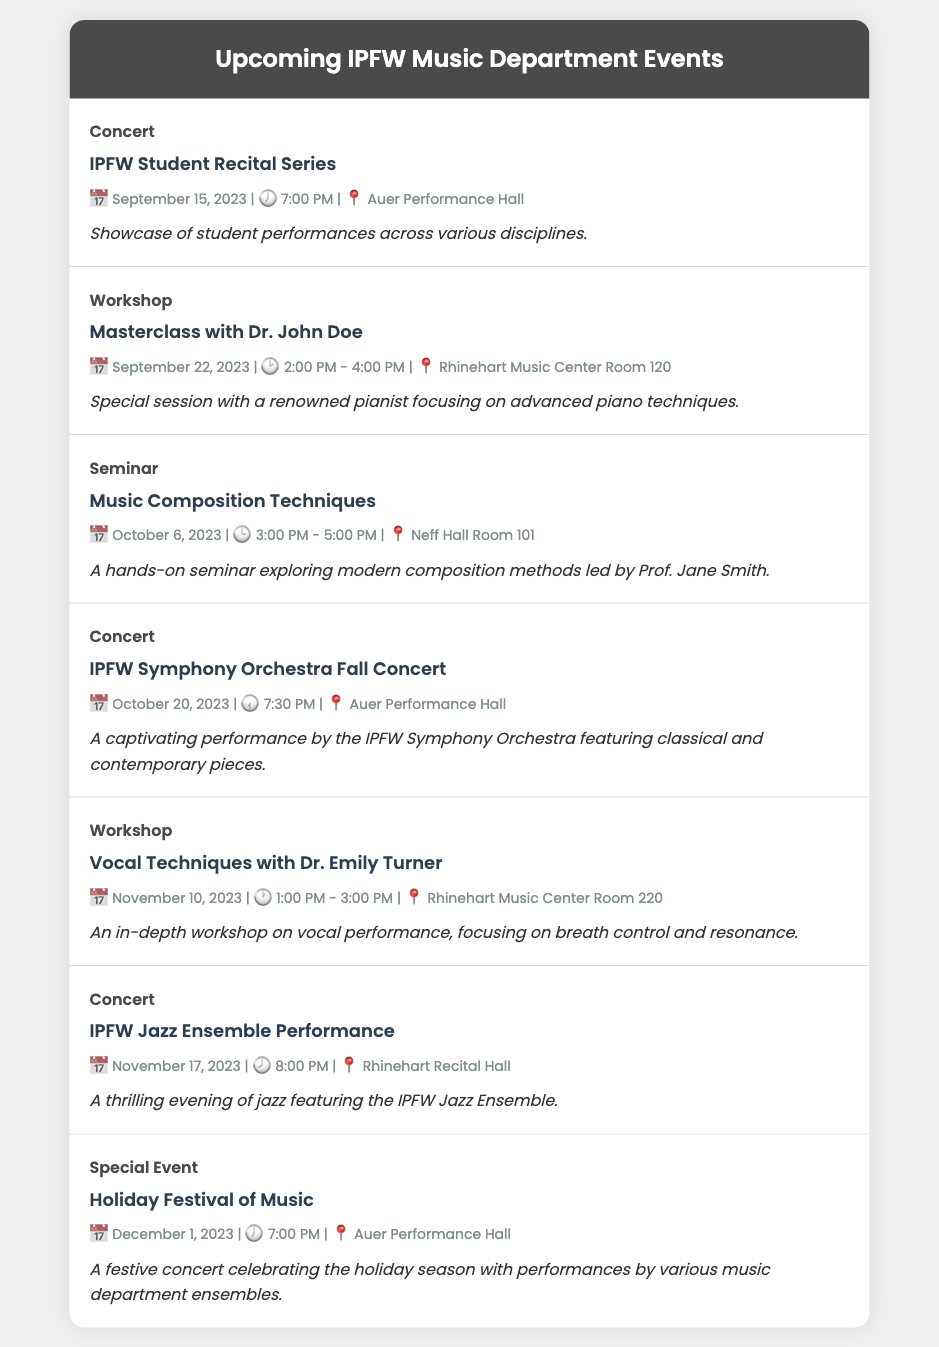What is the date of the IPFW Student Recital Series? The document lists the date of the IPFW Student Recital Series as September 15, 2023.
Answer: September 15, 2023 Who is leading the Masterclass on September 22, 2023? The Masterclass on September 22, 2023 is led by Dr. John Doe.
Answer: Dr. John Doe What type of event is the Holiday Festival of Music? The Holiday Festival of Music is categorized as a Special Event in the document.
Answer: Special Event What time does the IPFW Symphony Orchestra Fall Concert start? The IPFW Symphony Orchestra Fall Concert starts at 7:30 PM according to the document.
Answer: 7:30 PM How many concerts are listed in the document? The document lists three concerts, which are the Student Recital Series, the Symphony Orchestra Fall Concert, and the Jazz Ensemble Performance.
Answer: Three What is the location of the Vocal Techniques workshop? According to the document, the Vocal Techniques workshop is held in Rhinehart Music Center Room 220.
Answer: Rhinehart Music Center Room 220 What is the description of the Music Composition Techniques seminar? The document describes the seminar as a hands-on seminar exploring modern composition methods led by Prof. Jane Smith.
Answer: A hands-on seminar exploring modern composition methods led by Prof. Jane Smith When is the IPFW Jazz Ensemble Performance scheduled? The performance is scheduled for November 17, 2023 as stated in the document.
Answer: November 17, 2023 